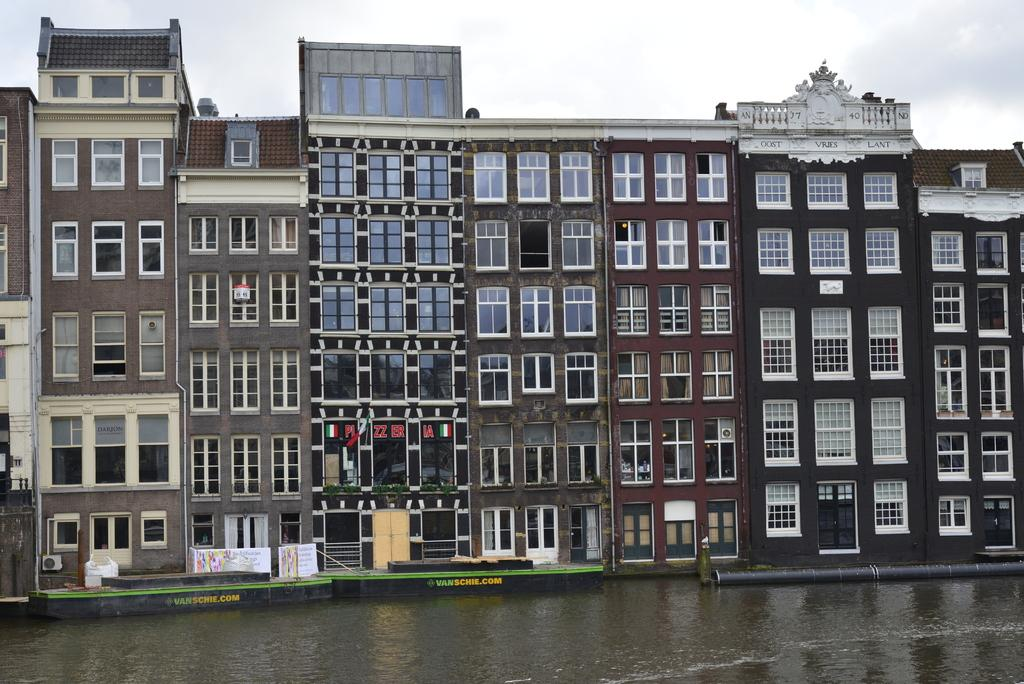What type of structures can be seen in the image? There are buildings in the image. What feature can be found on the buildings? There are windows in the image. What appliance is visible in the image? There is an air conditioner in the image. What type of decorations are present in the image? There are posters in the image. What natural element is visible in the image? There is water visible in the image. What part of the environment is visible in the image? The sky is visible in the image. How many eggs are being held by the friends in the image? There are no friends or eggs present in the image. What type of heart-shaped object can be seen in the image? There is no heart-shaped object present in the image. 